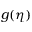<formula> <loc_0><loc_0><loc_500><loc_500>g ( \eta )</formula> 